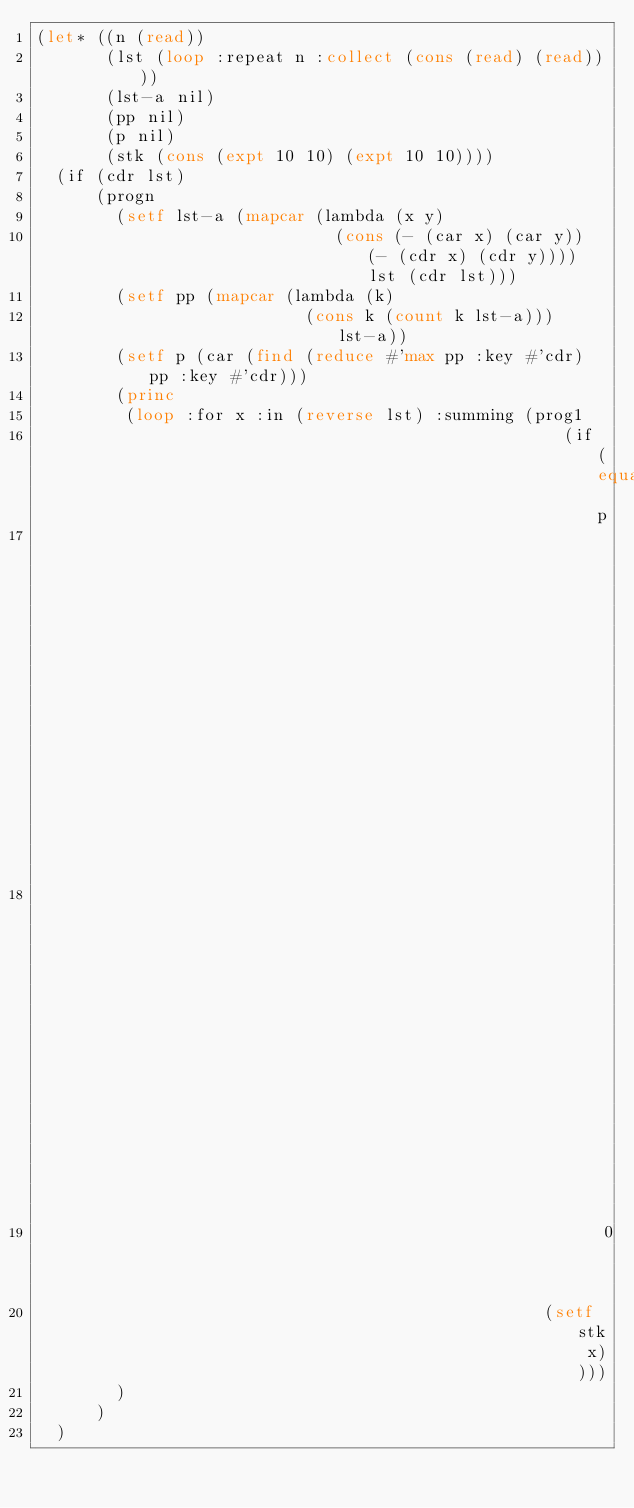Convert code to text. <code><loc_0><loc_0><loc_500><loc_500><_Lisp_>(let* ((n (read))
       (lst (loop :repeat n :collect (cons (read) (read))))
       (lst-a nil)
       (pp nil)
       (p nil)
       (stk (cons (expt 10 10) (expt 10 10))))
  (if (cdr lst)
      (progn
        (setf lst-a (mapcar (lambda (x y)
                              (cons (- (car x) (car y)) (- (cdr x) (cdr y)))) lst (cdr lst)))
        (setf pp (mapcar (lambda (k)
                           (cons k (count k lst-a))) lst-a))
        (setf p (car (find (reduce #'max pp :key #'cdr) pp :key #'cdr)))
        (princ
         (loop :for x :in (reverse lst) :summing (prog1
                                                     (if (equal p
                                                                (cons (- (car x) (car stk))
                                                                      (- (cdr x) (cdr stk))))
                                                         0 1)
                                                   (setf stk x))))
        )
      )
  )</code> 